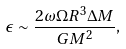<formula> <loc_0><loc_0><loc_500><loc_500>\epsilon \sim \frac { 2 \omega \Omega R ^ { 3 } \Delta M } { G M ^ { 2 } } ,</formula> 